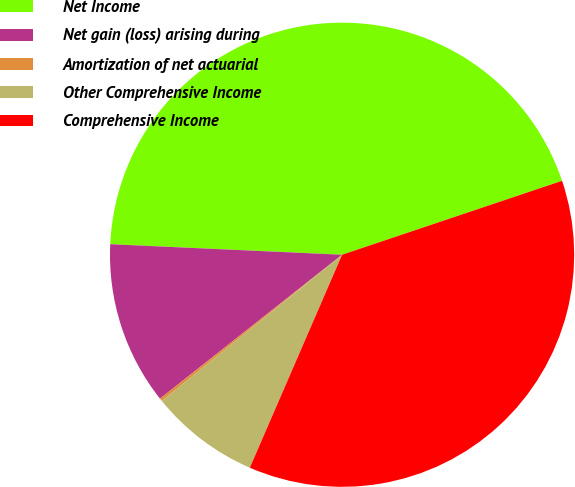<chart> <loc_0><loc_0><loc_500><loc_500><pie_chart><fcel>Net Income<fcel>Net gain (loss) arising during<fcel>Amortization of net actuarial<fcel>Other Comprehensive Income<fcel>Comprehensive Income<nl><fcel>44.12%<fcel>11.37%<fcel>0.2%<fcel>7.65%<fcel>36.67%<nl></chart> 